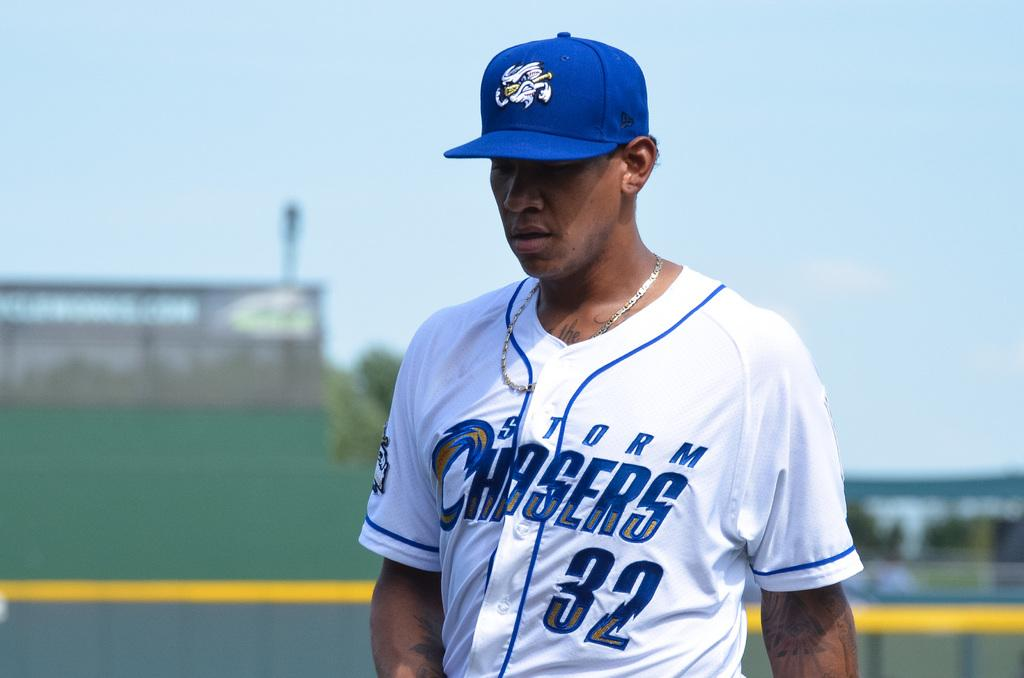<image>
Relay a brief, clear account of the picture shown. Baseball player number 32 from the storm chasers. 